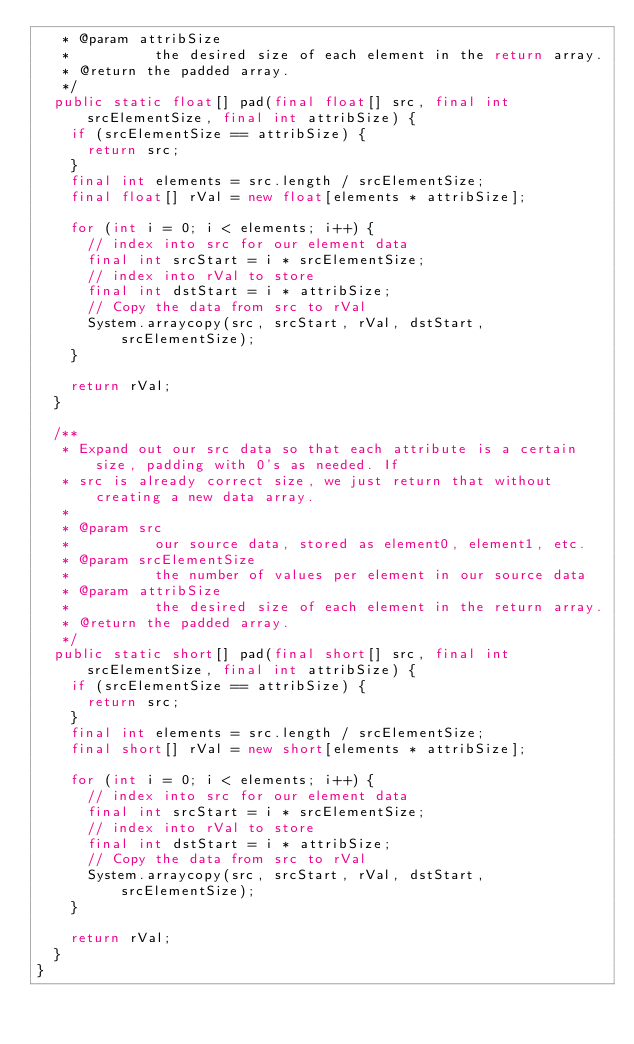Convert code to text. <code><loc_0><loc_0><loc_500><loc_500><_Java_>   * @param attribSize
   *          the desired size of each element in the return array.
   * @return the padded array.
   */
  public static float[] pad(final float[] src, final int srcElementSize, final int attribSize) {
    if (srcElementSize == attribSize) {
      return src;
    }
    final int elements = src.length / srcElementSize;
    final float[] rVal = new float[elements * attribSize];

    for (int i = 0; i < elements; i++) {
      // index into src for our element data
      final int srcStart = i * srcElementSize;
      // index into rVal to store
      final int dstStart = i * attribSize;
      // Copy the data from src to rVal
      System.arraycopy(src, srcStart, rVal, dstStart, srcElementSize);
    }

    return rVal;
  }

  /**
   * Expand out our src data so that each attribute is a certain size, padding with 0's as needed. If
   * src is already correct size, we just return that without creating a new data array.
   *
   * @param src
   *          our source data, stored as element0, element1, etc.
   * @param srcElementSize
   *          the number of values per element in our source data
   * @param attribSize
   *          the desired size of each element in the return array.
   * @return the padded array.
   */
  public static short[] pad(final short[] src, final int srcElementSize, final int attribSize) {
    if (srcElementSize == attribSize) {
      return src;
    }
    final int elements = src.length / srcElementSize;
    final short[] rVal = new short[elements * attribSize];

    for (int i = 0; i < elements; i++) {
      // index into src for our element data
      final int srcStart = i * srcElementSize;
      // index into rVal to store
      final int dstStart = i * attribSize;
      // Copy the data from src to rVal
      System.arraycopy(src, srcStart, rVal, dstStart, srcElementSize);
    }

    return rVal;
  }
}
</code> 